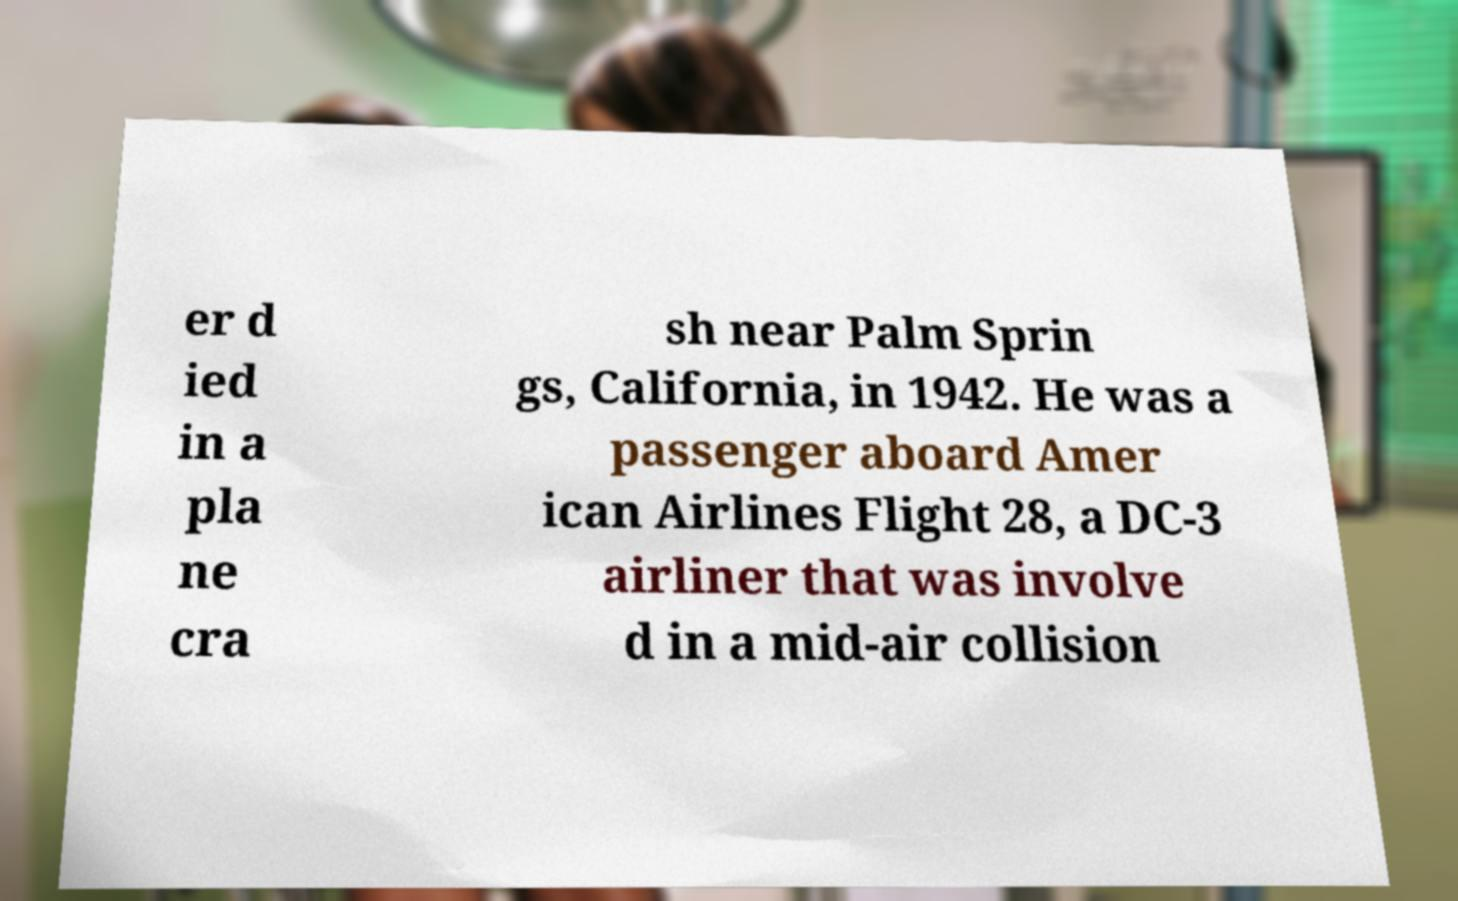There's text embedded in this image that I need extracted. Can you transcribe it verbatim? er d ied in a pla ne cra sh near Palm Sprin gs, California, in 1942. He was a passenger aboard Amer ican Airlines Flight 28, a DC-3 airliner that was involve d in a mid-air collision 